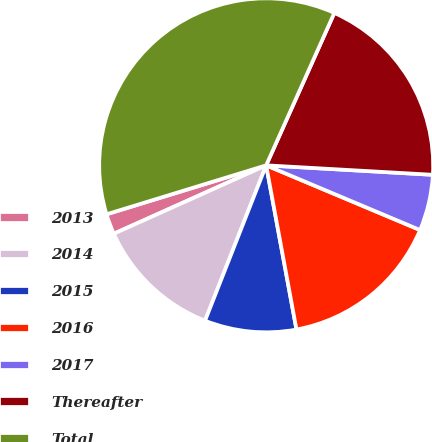Convert chart. <chart><loc_0><loc_0><loc_500><loc_500><pie_chart><fcel>2013<fcel>2014<fcel>2015<fcel>2016<fcel>2017<fcel>Thereafter<fcel>Total<nl><fcel>1.98%<fcel>12.32%<fcel>8.87%<fcel>15.76%<fcel>5.43%<fcel>19.21%<fcel>36.43%<nl></chart> 